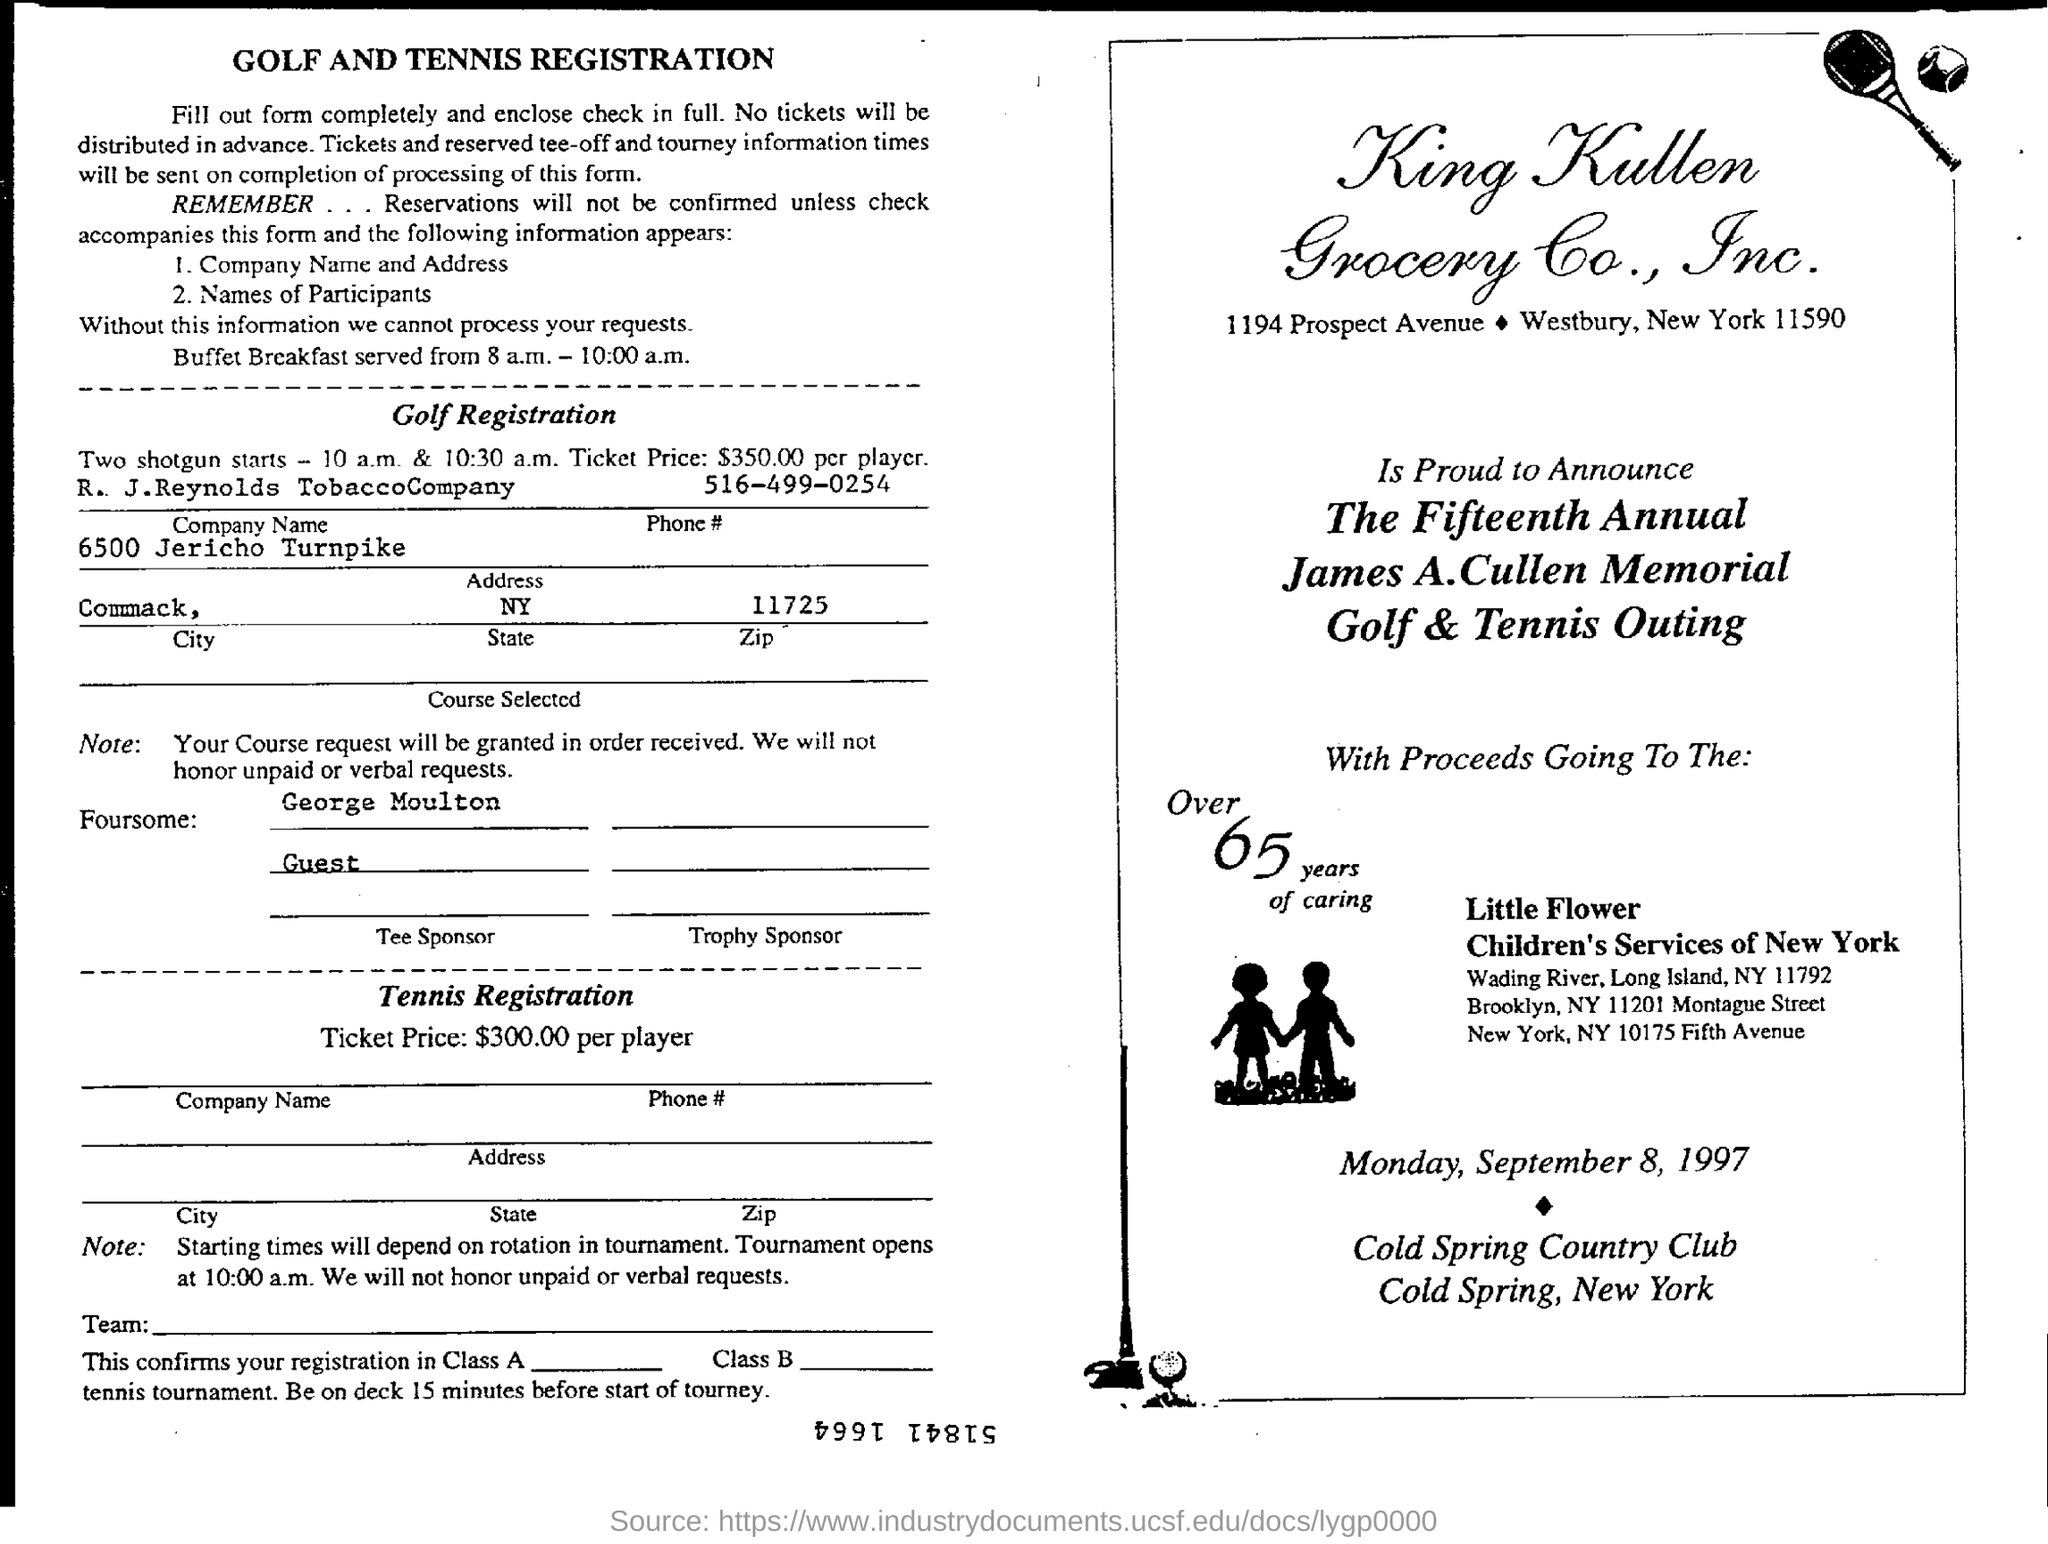What is the timing of Buffet Breakfast?
Offer a very short reply. 8 a.m. - 10:00 a.m. What is the ticket price for golf registration?
Offer a very short reply. $350.00 per player. What is the ticket price for tennis registration?
Ensure brevity in your answer.  $300.00. When is the Golf & Tennis Outing going to be held?
Give a very brief answer. Monday, September 8, 1997. 